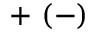<formula> <loc_0><loc_0><loc_500><loc_500>+ \ ( - )</formula> 